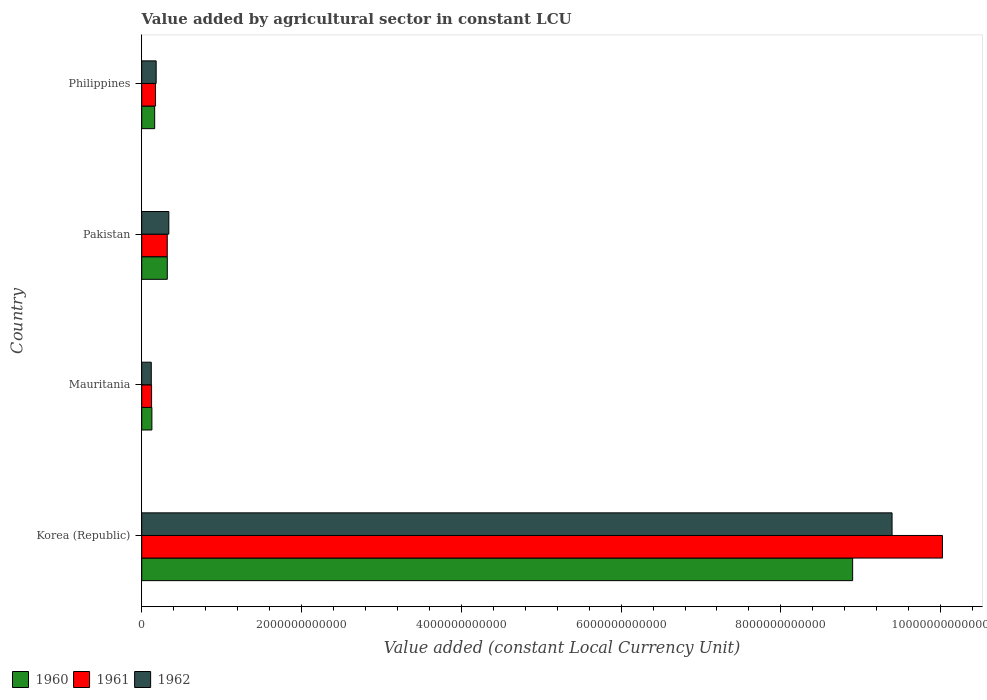How many groups of bars are there?
Provide a short and direct response. 4. Are the number of bars per tick equal to the number of legend labels?
Make the answer very short. Yes. Are the number of bars on each tick of the Y-axis equal?
Provide a short and direct response. Yes. What is the label of the 4th group of bars from the top?
Offer a terse response. Korea (Republic). What is the value added by agricultural sector in 1961 in Korea (Republic)?
Your answer should be very brief. 1.00e+13. Across all countries, what is the maximum value added by agricultural sector in 1962?
Give a very brief answer. 9.39e+12. Across all countries, what is the minimum value added by agricultural sector in 1962?
Your answer should be very brief. 1.20e+11. In which country was the value added by agricultural sector in 1960 minimum?
Keep it short and to the point. Mauritania. What is the total value added by agricultural sector in 1961 in the graph?
Your answer should be very brief. 1.06e+13. What is the difference between the value added by agricultural sector in 1960 in Mauritania and that in Philippines?
Ensure brevity in your answer.  -3.47e+1. What is the difference between the value added by agricultural sector in 1961 in Mauritania and the value added by agricultural sector in 1960 in Korea (Republic)?
Provide a succinct answer. -8.77e+12. What is the average value added by agricultural sector in 1961 per country?
Offer a terse response. 2.66e+12. What is the difference between the value added by agricultural sector in 1962 and value added by agricultural sector in 1961 in Korea (Republic)?
Provide a succinct answer. -6.31e+11. What is the ratio of the value added by agricultural sector in 1962 in Korea (Republic) to that in Philippines?
Keep it short and to the point. 51.98. What is the difference between the highest and the second highest value added by agricultural sector in 1960?
Give a very brief answer. 8.58e+12. What is the difference between the highest and the lowest value added by agricultural sector in 1962?
Your answer should be very brief. 9.27e+12. What does the 3rd bar from the top in Pakistan represents?
Keep it short and to the point. 1960. What does the 3rd bar from the bottom in Korea (Republic) represents?
Ensure brevity in your answer.  1962. What is the difference between two consecutive major ticks on the X-axis?
Provide a short and direct response. 2.00e+12. How many legend labels are there?
Make the answer very short. 3. What is the title of the graph?
Your answer should be compact. Value added by agricultural sector in constant LCU. What is the label or title of the X-axis?
Make the answer very short. Value added (constant Local Currency Unit). What is the label or title of the Y-axis?
Offer a very short reply. Country. What is the Value added (constant Local Currency Unit) in 1960 in Korea (Republic)?
Keep it short and to the point. 8.90e+12. What is the Value added (constant Local Currency Unit) of 1961 in Korea (Republic)?
Your answer should be compact. 1.00e+13. What is the Value added (constant Local Currency Unit) of 1962 in Korea (Republic)?
Ensure brevity in your answer.  9.39e+12. What is the Value added (constant Local Currency Unit) in 1960 in Mauritania?
Give a very brief answer. 1.27e+11. What is the Value added (constant Local Currency Unit) of 1961 in Mauritania?
Make the answer very short. 1.23e+11. What is the Value added (constant Local Currency Unit) of 1962 in Mauritania?
Your answer should be compact. 1.20e+11. What is the Value added (constant Local Currency Unit) in 1960 in Pakistan?
Ensure brevity in your answer.  3.20e+11. What is the Value added (constant Local Currency Unit) in 1961 in Pakistan?
Keep it short and to the point. 3.19e+11. What is the Value added (constant Local Currency Unit) in 1962 in Pakistan?
Your answer should be compact. 3.39e+11. What is the Value added (constant Local Currency Unit) of 1960 in Philippines?
Provide a succinct answer. 1.62e+11. What is the Value added (constant Local Currency Unit) of 1961 in Philippines?
Your answer should be very brief. 1.73e+11. What is the Value added (constant Local Currency Unit) in 1962 in Philippines?
Provide a short and direct response. 1.81e+11. Across all countries, what is the maximum Value added (constant Local Currency Unit) of 1960?
Your answer should be compact. 8.90e+12. Across all countries, what is the maximum Value added (constant Local Currency Unit) in 1961?
Make the answer very short. 1.00e+13. Across all countries, what is the maximum Value added (constant Local Currency Unit) in 1962?
Your response must be concise. 9.39e+12. Across all countries, what is the minimum Value added (constant Local Currency Unit) in 1960?
Your response must be concise. 1.27e+11. Across all countries, what is the minimum Value added (constant Local Currency Unit) in 1961?
Offer a terse response. 1.23e+11. Across all countries, what is the minimum Value added (constant Local Currency Unit) in 1962?
Provide a short and direct response. 1.20e+11. What is the total Value added (constant Local Currency Unit) in 1960 in the graph?
Offer a very short reply. 9.51e+12. What is the total Value added (constant Local Currency Unit) of 1961 in the graph?
Your response must be concise. 1.06e+13. What is the total Value added (constant Local Currency Unit) of 1962 in the graph?
Your answer should be very brief. 1.00e+13. What is the difference between the Value added (constant Local Currency Unit) of 1960 in Korea (Republic) and that in Mauritania?
Your answer should be very brief. 8.77e+12. What is the difference between the Value added (constant Local Currency Unit) of 1961 in Korea (Republic) and that in Mauritania?
Provide a short and direct response. 9.90e+12. What is the difference between the Value added (constant Local Currency Unit) in 1962 in Korea (Republic) and that in Mauritania?
Provide a succinct answer. 9.27e+12. What is the difference between the Value added (constant Local Currency Unit) of 1960 in Korea (Republic) and that in Pakistan?
Make the answer very short. 8.58e+12. What is the difference between the Value added (constant Local Currency Unit) in 1961 in Korea (Republic) and that in Pakistan?
Your answer should be compact. 9.70e+12. What is the difference between the Value added (constant Local Currency Unit) of 1962 in Korea (Republic) and that in Pakistan?
Offer a very short reply. 9.05e+12. What is the difference between the Value added (constant Local Currency Unit) in 1960 in Korea (Republic) and that in Philippines?
Ensure brevity in your answer.  8.74e+12. What is the difference between the Value added (constant Local Currency Unit) in 1961 in Korea (Republic) and that in Philippines?
Your answer should be compact. 9.85e+12. What is the difference between the Value added (constant Local Currency Unit) of 1962 in Korea (Republic) and that in Philippines?
Keep it short and to the point. 9.21e+12. What is the difference between the Value added (constant Local Currency Unit) of 1960 in Mauritania and that in Pakistan?
Provide a succinct answer. -1.93e+11. What is the difference between the Value added (constant Local Currency Unit) of 1961 in Mauritania and that in Pakistan?
Ensure brevity in your answer.  -1.96e+11. What is the difference between the Value added (constant Local Currency Unit) in 1962 in Mauritania and that in Pakistan?
Offer a very short reply. -2.20e+11. What is the difference between the Value added (constant Local Currency Unit) of 1960 in Mauritania and that in Philippines?
Make the answer very short. -3.47e+1. What is the difference between the Value added (constant Local Currency Unit) of 1961 in Mauritania and that in Philippines?
Keep it short and to the point. -4.95e+1. What is the difference between the Value added (constant Local Currency Unit) of 1962 in Mauritania and that in Philippines?
Keep it short and to the point. -6.11e+1. What is the difference between the Value added (constant Local Currency Unit) in 1960 in Pakistan and that in Philippines?
Your answer should be very brief. 1.58e+11. What is the difference between the Value added (constant Local Currency Unit) in 1961 in Pakistan and that in Philippines?
Your response must be concise. 1.47e+11. What is the difference between the Value added (constant Local Currency Unit) of 1962 in Pakistan and that in Philippines?
Offer a very short reply. 1.58e+11. What is the difference between the Value added (constant Local Currency Unit) of 1960 in Korea (Republic) and the Value added (constant Local Currency Unit) of 1961 in Mauritania?
Your answer should be compact. 8.77e+12. What is the difference between the Value added (constant Local Currency Unit) of 1960 in Korea (Republic) and the Value added (constant Local Currency Unit) of 1962 in Mauritania?
Keep it short and to the point. 8.78e+12. What is the difference between the Value added (constant Local Currency Unit) of 1961 in Korea (Republic) and the Value added (constant Local Currency Unit) of 1962 in Mauritania?
Keep it short and to the point. 9.90e+12. What is the difference between the Value added (constant Local Currency Unit) of 1960 in Korea (Republic) and the Value added (constant Local Currency Unit) of 1961 in Pakistan?
Your response must be concise. 8.58e+12. What is the difference between the Value added (constant Local Currency Unit) of 1960 in Korea (Republic) and the Value added (constant Local Currency Unit) of 1962 in Pakistan?
Keep it short and to the point. 8.56e+12. What is the difference between the Value added (constant Local Currency Unit) in 1961 in Korea (Republic) and the Value added (constant Local Currency Unit) in 1962 in Pakistan?
Your answer should be compact. 9.68e+12. What is the difference between the Value added (constant Local Currency Unit) of 1960 in Korea (Republic) and the Value added (constant Local Currency Unit) of 1961 in Philippines?
Provide a short and direct response. 8.73e+12. What is the difference between the Value added (constant Local Currency Unit) of 1960 in Korea (Republic) and the Value added (constant Local Currency Unit) of 1962 in Philippines?
Ensure brevity in your answer.  8.72e+12. What is the difference between the Value added (constant Local Currency Unit) in 1961 in Korea (Republic) and the Value added (constant Local Currency Unit) in 1962 in Philippines?
Ensure brevity in your answer.  9.84e+12. What is the difference between the Value added (constant Local Currency Unit) of 1960 in Mauritania and the Value added (constant Local Currency Unit) of 1961 in Pakistan?
Make the answer very short. -1.92e+11. What is the difference between the Value added (constant Local Currency Unit) of 1960 in Mauritania and the Value added (constant Local Currency Unit) of 1962 in Pakistan?
Provide a short and direct response. -2.12e+11. What is the difference between the Value added (constant Local Currency Unit) of 1961 in Mauritania and the Value added (constant Local Currency Unit) of 1962 in Pakistan?
Offer a very short reply. -2.16e+11. What is the difference between the Value added (constant Local Currency Unit) in 1960 in Mauritania and the Value added (constant Local Currency Unit) in 1961 in Philippines?
Provide a short and direct response. -4.55e+1. What is the difference between the Value added (constant Local Currency Unit) of 1960 in Mauritania and the Value added (constant Local Currency Unit) of 1962 in Philippines?
Give a very brief answer. -5.34e+1. What is the difference between the Value added (constant Local Currency Unit) of 1961 in Mauritania and the Value added (constant Local Currency Unit) of 1962 in Philippines?
Your answer should be very brief. -5.74e+1. What is the difference between the Value added (constant Local Currency Unit) of 1960 in Pakistan and the Value added (constant Local Currency Unit) of 1961 in Philippines?
Keep it short and to the point. 1.47e+11. What is the difference between the Value added (constant Local Currency Unit) of 1960 in Pakistan and the Value added (constant Local Currency Unit) of 1962 in Philippines?
Offer a very short reply. 1.39e+11. What is the difference between the Value added (constant Local Currency Unit) of 1961 in Pakistan and the Value added (constant Local Currency Unit) of 1962 in Philippines?
Ensure brevity in your answer.  1.39e+11. What is the average Value added (constant Local Currency Unit) of 1960 per country?
Make the answer very short. 2.38e+12. What is the average Value added (constant Local Currency Unit) of 1961 per country?
Keep it short and to the point. 2.66e+12. What is the average Value added (constant Local Currency Unit) of 1962 per country?
Provide a short and direct response. 2.51e+12. What is the difference between the Value added (constant Local Currency Unit) in 1960 and Value added (constant Local Currency Unit) in 1961 in Korea (Republic)?
Keep it short and to the point. -1.12e+12. What is the difference between the Value added (constant Local Currency Unit) of 1960 and Value added (constant Local Currency Unit) of 1962 in Korea (Republic)?
Provide a short and direct response. -4.93e+11. What is the difference between the Value added (constant Local Currency Unit) in 1961 and Value added (constant Local Currency Unit) in 1962 in Korea (Republic)?
Your response must be concise. 6.31e+11. What is the difference between the Value added (constant Local Currency Unit) in 1960 and Value added (constant Local Currency Unit) in 1961 in Mauritania?
Give a very brief answer. 4.01e+09. What is the difference between the Value added (constant Local Currency Unit) of 1960 and Value added (constant Local Currency Unit) of 1962 in Mauritania?
Your answer should be very brief. 7.67e+09. What is the difference between the Value added (constant Local Currency Unit) of 1961 and Value added (constant Local Currency Unit) of 1962 in Mauritania?
Your answer should be compact. 3.65e+09. What is the difference between the Value added (constant Local Currency Unit) in 1960 and Value added (constant Local Currency Unit) in 1961 in Pakistan?
Provide a short and direct response. 6.46e+08. What is the difference between the Value added (constant Local Currency Unit) of 1960 and Value added (constant Local Currency Unit) of 1962 in Pakistan?
Your answer should be very brief. -1.91e+1. What is the difference between the Value added (constant Local Currency Unit) of 1961 and Value added (constant Local Currency Unit) of 1962 in Pakistan?
Provide a succinct answer. -1.97e+1. What is the difference between the Value added (constant Local Currency Unit) of 1960 and Value added (constant Local Currency Unit) of 1961 in Philippines?
Provide a short and direct response. -1.08e+1. What is the difference between the Value added (constant Local Currency Unit) in 1960 and Value added (constant Local Currency Unit) in 1962 in Philippines?
Your answer should be very brief. -1.87e+1. What is the difference between the Value added (constant Local Currency Unit) in 1961 and Value added (constant Local Currency Unit) in 1962 in Philippines?
Offer a terse response. -7.86e+09. What is the ratio of the Value added (constant Local Currency Unit) in 1960 in Korea (Republic) to that in Mauritania?
Provide a short and direct response. 69.9. What is the ratio of the Value added (constant Local Currency Unit) in 1961 in Korea (Republic) to that in Mauritania?
Your response must be concise. 81.29. What is the ratio of the Value added (constant Local Currency Unit) of 1962 in Korea (Republic) to that in Mauritania?
Offer a very short reply. 78.51. What is the ratio of the Value added (constant Local Currency Unit) of 1960 in Korea (Republic) to that in Pakistan?
Offer a terse response. 27.8. What is the ratio of the Value added (constant Local Currency Unit) of 1961 in Korea (Republic) to that in Pakistan?
Offer a terse response. 31.38. What is the ratio of the Value added (constant Local Currency Unit) of 1962 in Korea (Republic) to that in Pakistan?
Offer a very short reply. 27.69. What is the ratio of the Value added (constant Local Currency Unit) in 1960 in Korea (Republic) to that in Philippines?
Provide a short and direct response. 54.93. What is the ratio of the Value added (constant Local Currency Unit) in 1961 in Korea (Republic) to that in Philippines?
Offer a very short reply. 57.99. What is the ratio of the Value added (constant Local Currency Unit) of 1962 in Korea (Republic) to that in Philippines?
Your answer should be compact. 51.98. What is the ratio of the Value added (constant Local Currency Unit) of 1960 in Mauritania to that in Pakistan?
Give a very brief answer. 0.4. What is the ratio of the Value added (constant Local Currency Unit) in 1961 in Mauritania to that in Pakistan?
Offer a very short reply. 0.39. What is the ratio of the Value added (constant Local Currency Unit) in 1962 in Mauritania to that in Pakistan?
Make the answer very short. 0.35. What is the ratio of the Value added (constant Local Currency Unit) of 1960 in Mauritania to that in Philippines?
Ensure brevity in your answer.  0.79. What is the ratio of the Value added (constant Local Currency Unit) in 1961 in Mauritania to that in Philippines?
Your response must be concise. 0.71. What is the ratio of the Value added (constant Local Currency Unit) in 1962 in Mauritania to that in Philippines?
Offer a very short reply. 0.66. What is the ratio of the Value added (constant Local Currency Unit) in 1960 in Pakistan to that in Philippines?
Offer a very short reply. 1.98. What is the ratio of the Value added (constant Local Currency Unit) in 1961 in Pakistan to that in Philippines?
Ensure brevity in your answer.  1.85. What is the ratio of the Value added (constant Local Currency Unit) of 1962 in Pakistan to that in Philippines?
Provide a succinct answer. 1.88. What is the difference between the highest and the second highest Value added (constant Local Currency Unit) of 1960?
Give a very brief answer. 8.58e+12. What is the difference between the highest and the second highest Value added (constant Local Currency Unit) in 1961?
Your answer should be very brief. 9.70e+12. What is the difference between the highest and the second highest Value added (constant Local Currency Unit) in 1962?
Keep it short and to the point. 9.05e+12. What is the difference between the highest and the lowest Value added (constant Local Currency Unit) in 1960?
Your answer should be very brief. 8.77e+12. What is the difference between the highest and the lowest Value added (constant Local Currency Unit) of 1961?
Give a very brief answer. 9.90e+12. What is the difference between the highest and the lowest Value added (constant Local Currency Unit) of 1962?
Give a very brief answer. 9.27e+12. 